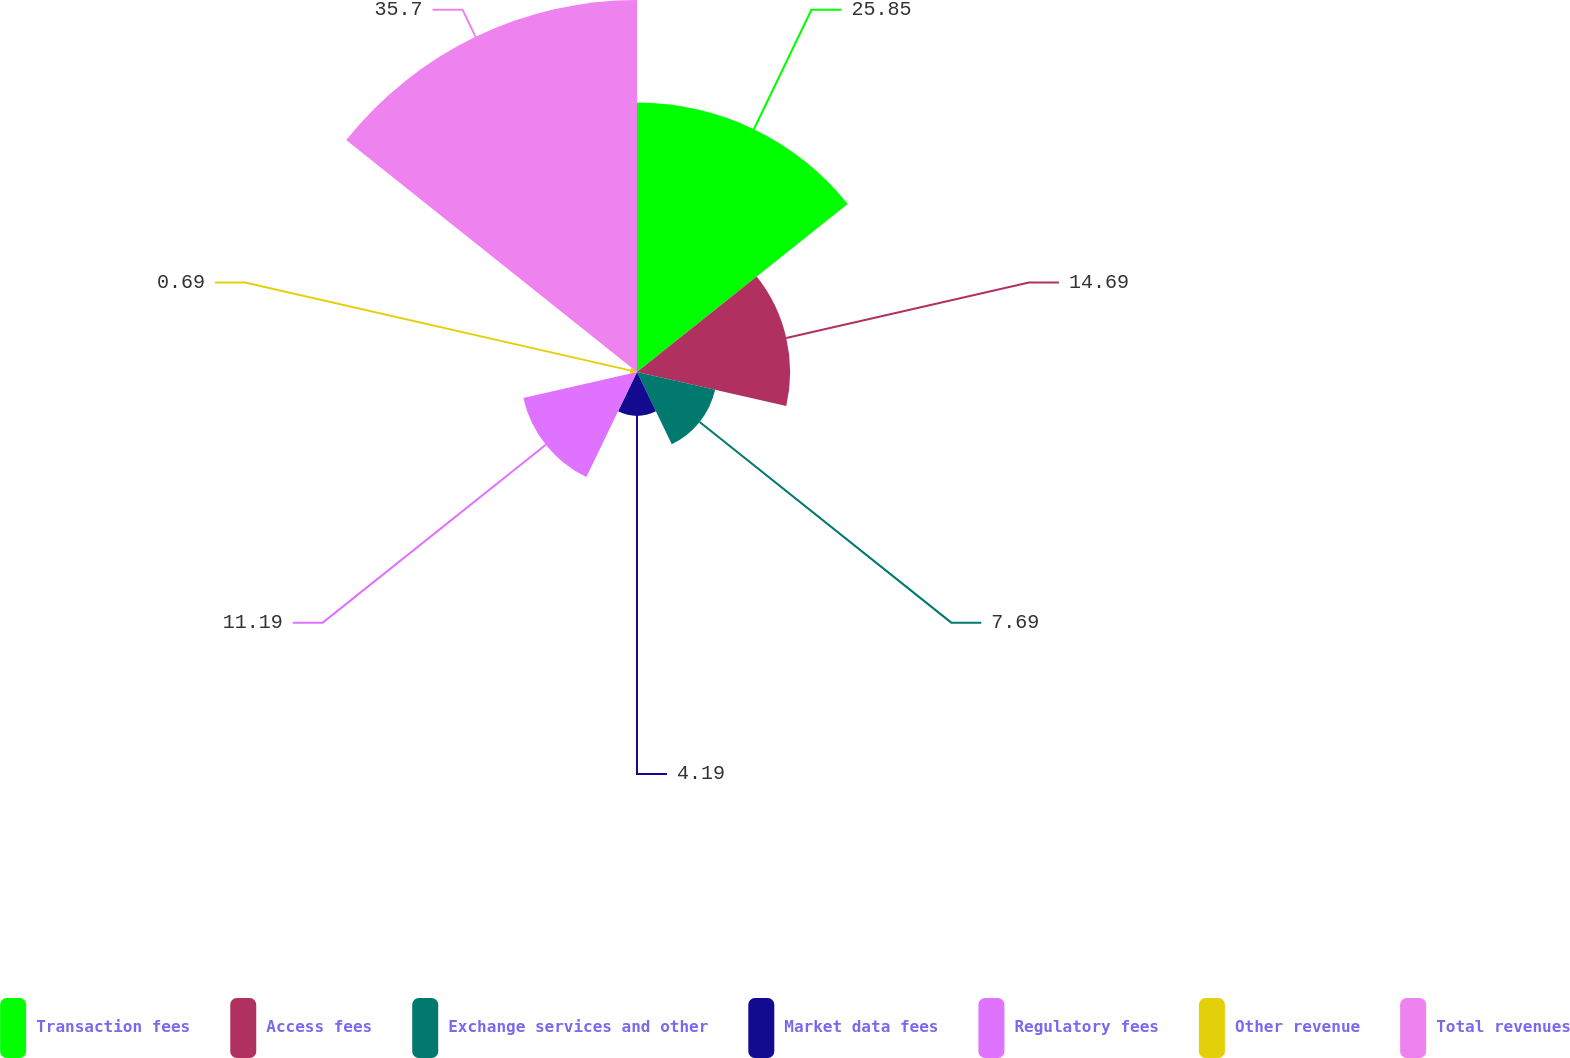Convert chart. <chart><loc_0><loc_0><loc_500><loc_500><pie_chart><fcel>Transaction fees<fcel>Access fees<fcel>Exchange services and other<fcel>Market data fees<fcel>Regulatory fees<fcel>Other revenue<fcel>Total revenues<nl><fcel>25.85%<fcel>14.69%<fcel>7.69%<fcel>4.19%<fcel>11.19%<fcel>0.69%<fcel>35.69%<nl></chart> 